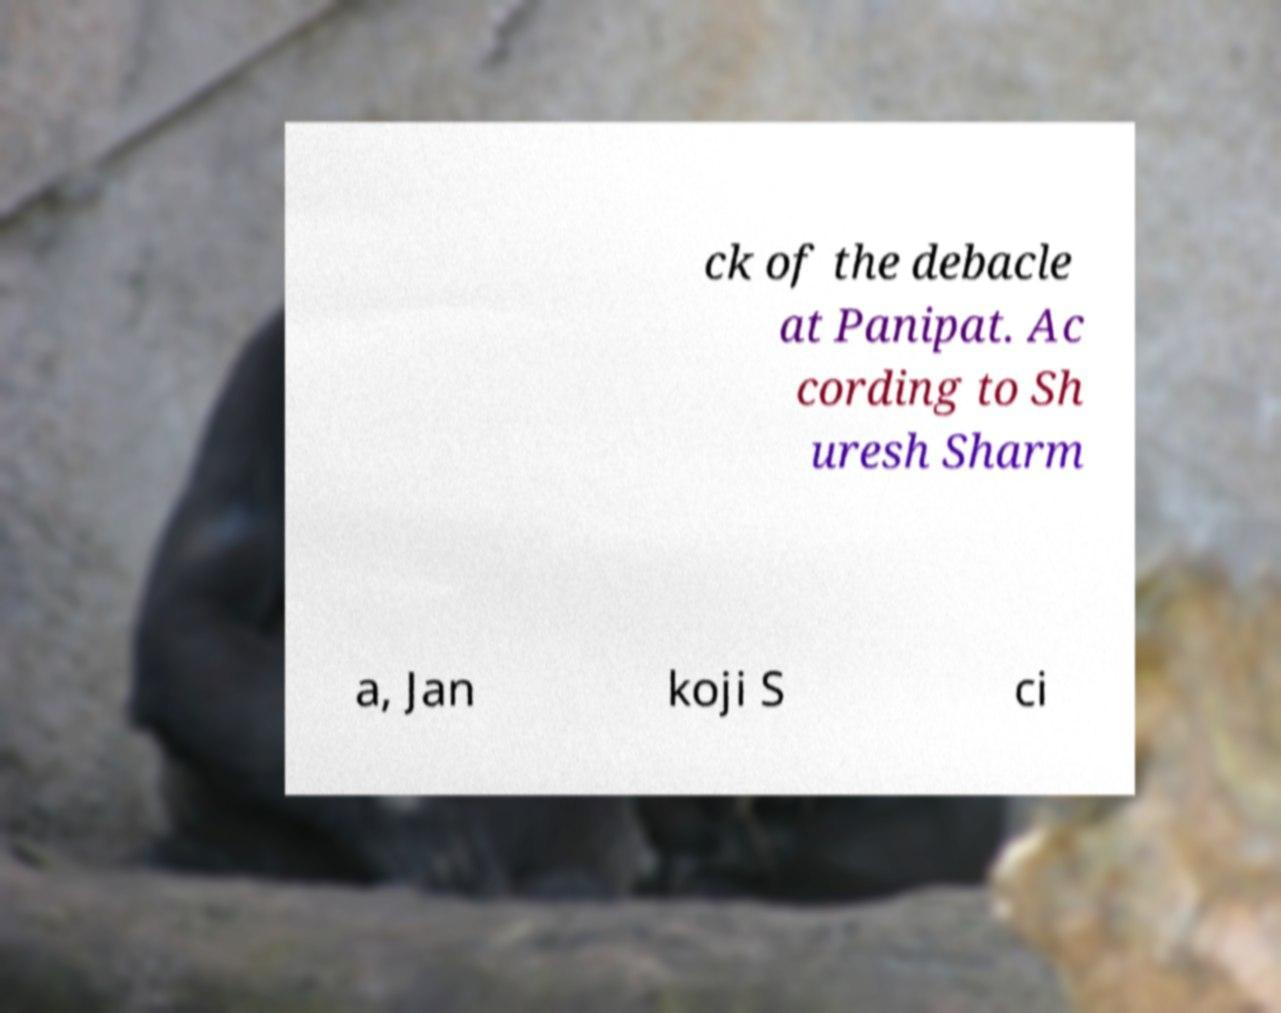What messages or text are displayed in this image? I need them in a readable, typed format. ck of the debacle at Panipat. Ac cording to Sh uresh Sharm a, Jan koji S ci 